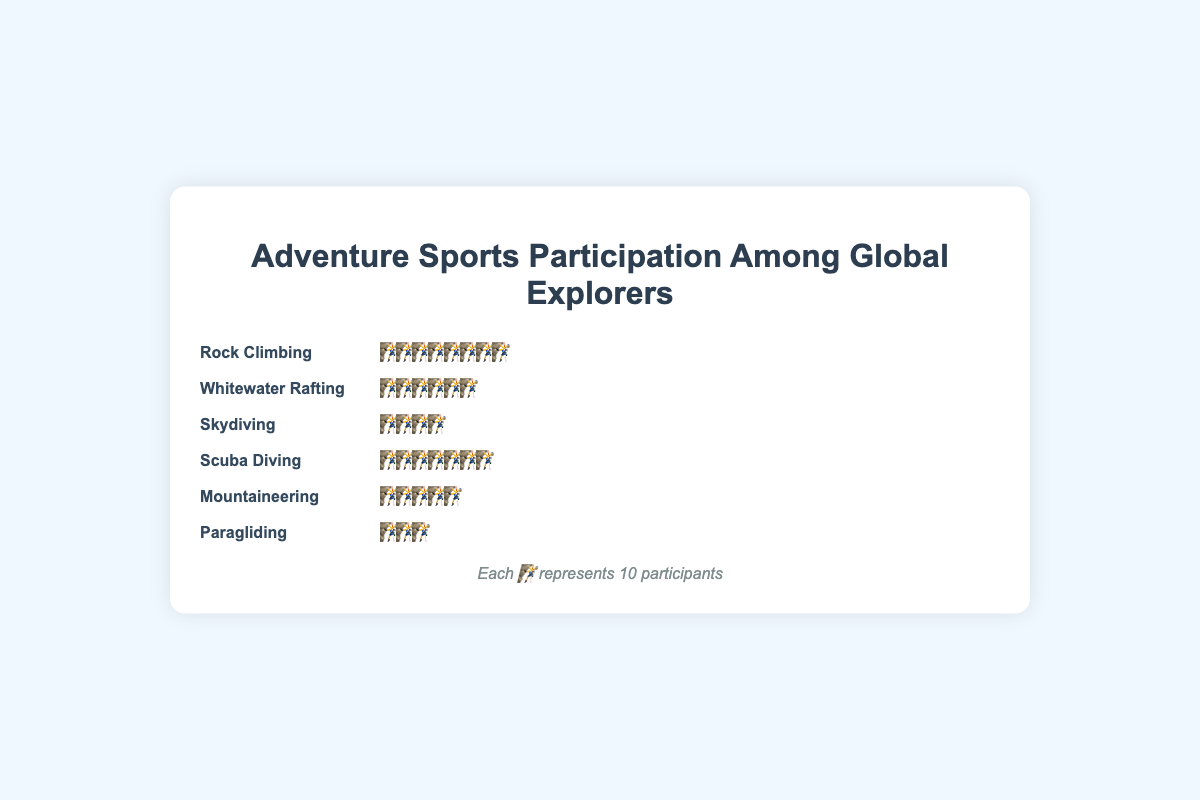Which adventure sport has the highest number of participants? The sport with the highest number of participants is the one with the most icons. In the chart, Rock Climbing has 8 icons. Multiply it by the unit value (10) gives 80 participants.
Answer: Rock Climbing Which adventure sport has the lowest number of participants? The sport with the lowest number of participants is the one with the fewest icons. Paragliding has 3 icons. Multiply it by the unit value (10) gives 30 participants.
Answer: Paragliding How many more participants did Scuba Diving have compared to Skydiving? First, determine the number of participants for Scuba Diving (7 icons) and Skydiving (4 icons). Then calculate the difference: 7 * 10 - 4 * 10 = 70 - 40 = 30.
Answer: 30 What is the total number of participants in all the adventure sports combined? Add up all the participants from each sport (8 + 6 + 4 + 7 + 5 + 3), then multiply by 10: (8 + 6 + 4 + 7 + 5 + 3) * 10 = 33 * 10 = 330.
Answer: 330 Which adventure sports have fewer than 5 icons? Only those sports with fewer than 5 icons are Skydiving (4) and Paragliding (3).
Answer: Skydiving, Paragliding What is the average number of participants for these adventure sports? First, find the total number of participants (330). Then divide by the number of sports: 330 / 6 ≈ 55.
Answer: 55 Which adventure sport has exactly 60 participants? Determine which sport has 6 icons, as each icon represents 10 participants. Whitewater Rafting has 6 icons.
Answer: Whitewater Rafting How many more participants are there in Rock Climbing compared to Mountaineering? Rock Climbing has 8 icons (80 participants), and Mountaineering has 5 icons (50 participants). The difference is 80 - 50 = 30.
Answer: 30 What percentage of the total participants are involved in Skydiving? Skydiving has 4 icons (40 participants) out of a total of 330 participants. The percentage is (40 / 330) * 100 ≈ 12.12%.
Answer: 12.12% 